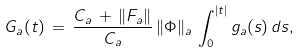<formula> <loc_0><loc_0><loc_500><loc_500>G _ { a } ( t ) \, = \, \frac { C _ { a } \, + \, \| F _ { a } \| } { C _ { a } } \, \| \Phi \| _ { a } \, \int _ { 0 } ^ { | t | } g _ { a } ( s ) \, d s ,</formula> 